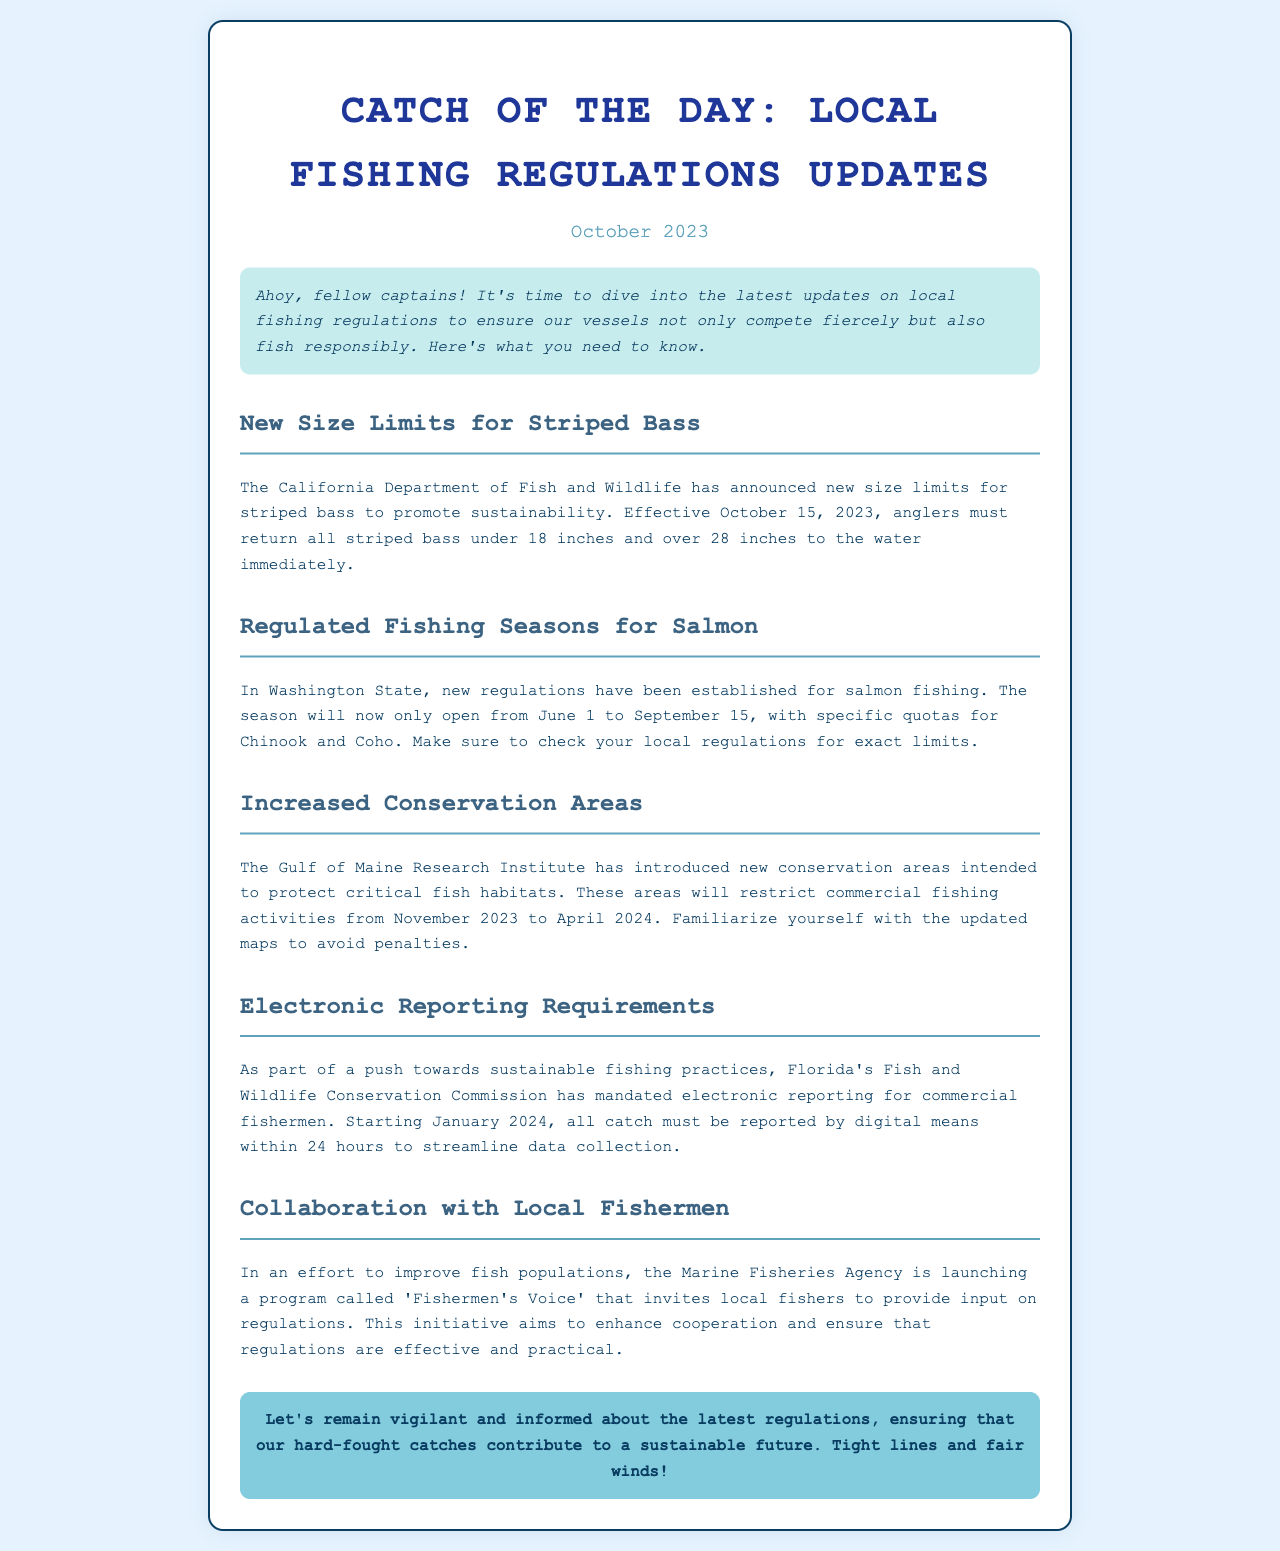What is the new size limit for striped bass? The document states that anglers must return all striped bass under 18 inches and over 28 inches to the water immediately.
Answer: 18 inches and 28 inches When does the salmon fishing season open? According to the document, the salmon fishing season will now only open from June 1 to September 15.
Answer: June 1 to September 15 What agency introduced new conservation areas in the Gulf of Maine? The Gulf of Maine Research Institute is mentioned as the agency that has introduced new conservation areas.
Answer: Gulf of Maine Research Institute What is the deadline for electronic reporting in Florida? The document specifies that electronic reporting must be completed within 24 hours starting January 2024.
Answer: January 2024 What program is aimed at collaborating with local fishermen? The initiative called 'Fishermen's Voice' is intended to improve cooperation with local fishers.
Answer: Fishermen's Voice How long will the conservation areas restrict commercial fishing activities? The document indicates that the conservation areas will restrict activities from November 2023 to April 2024.
Answer: November 2023 to April 2024 What is the purpose of the electronic reporting mandate? The reason stated in the document is to streamline data collection for sustainable fishing practices.
Answer: Streamline data collection Which fish species require specific quotas in the new salmon fishing regulations? The document mentions that there are specific quotas for Chinook and Coho salmon.
Answer: Chinook and Coho What is the main focus of the updates summarized in this newsletter? The document emphasizes the importance of staying informed and compliant with fishing regulations for sustainability.
Answer: Sustainability 